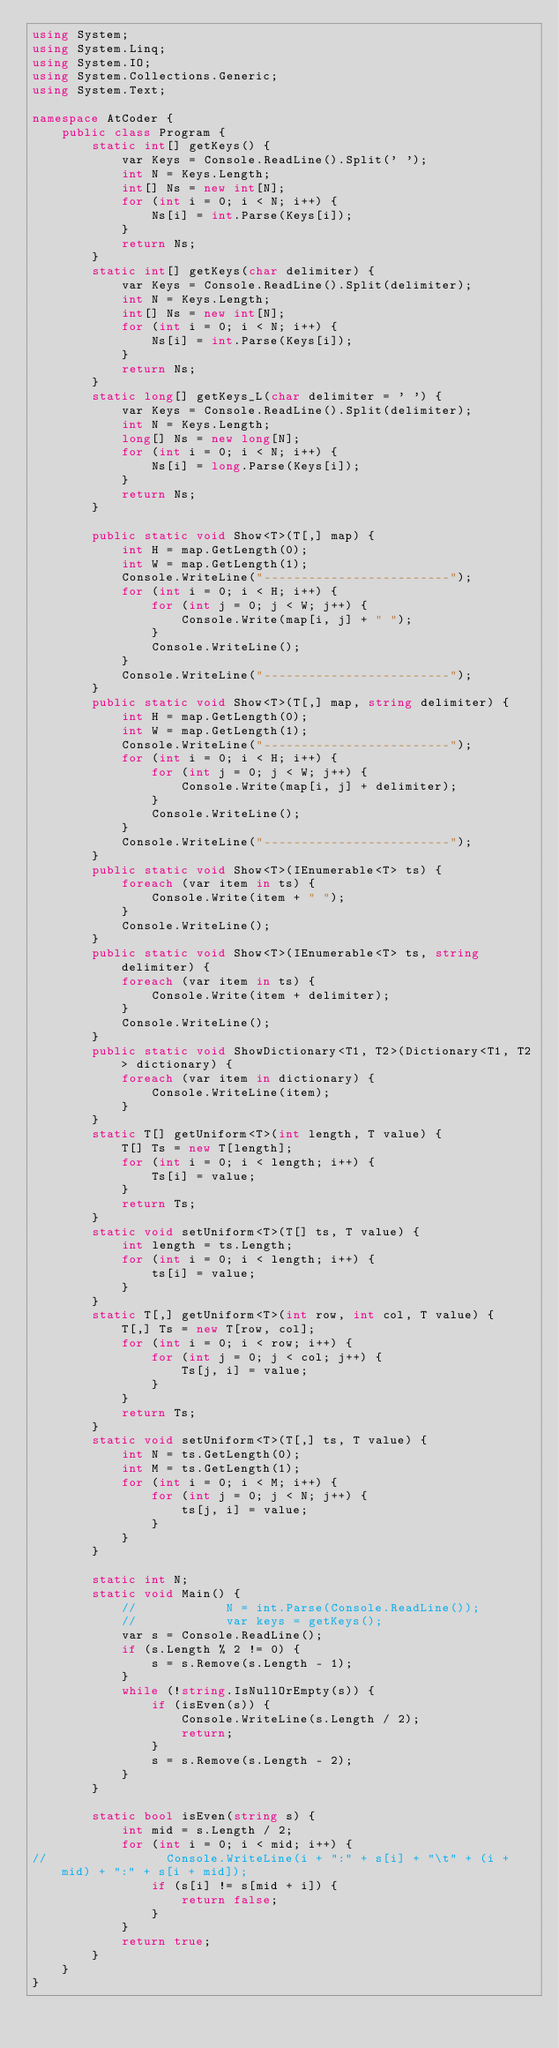<code> <loc_0><loc_0><loc_500><loc_500><_C#_>using System;
using System.Linq;
using System.IO;
using System.Collections.Generic;
using System.Text;

namespace AtCoder {
    public class Program {
        static int[] getKeys() {
            var Keys = Console.ReadLine().Split(' ');
            int N = Keys.Length;
            int[] Ns = new int[N];
            for (int i = 0; i < N; i++) {
                Ns[i] = int.Parse(Keys[i]);
            }
            return Ns;
        }
        static int[] getKeys(char delimiter) {
            var Keys = Console.ReadLine().Split(delimiter);
            int N = Keys.Length;
            int[] Ns = new int[N];
            for (int i = 0; i < N; i++) {
                Ns[i] = int.Parse(Keys[i]);
            }
            return Ns;
        }
        static long[] getKeys_L(char delimiter = ' ') {
            var Keys = Console.ReadLine().Split(delimiter);
            int N = Keys.Length;
            long[] Ns = new long[N];
            for (int i = 0; i < N; i++) {
                Ns[i] = long.Parse(Keys[i]);
            }
            return Ns;
        }

        public static void Show<T>(T[,] map) {
            int H = map.GetLength(0);
            int W = map.GetLength(1);
            Console.WriteLine("-------------------------");
            for (int i = 0; i < H; i++) {
                for (int j = 0; j < W; j++) {
                    Console.Write(map[i, j] + " ");
                }
                Console.WriteLine();
            }
            Console.WriteLine("-------------------------");
        }
        public static void Show<T>(T[,] map, string delimiter) {
            int H = map.GetLength(0);
            int W = map.GetLength(1);
            Console.WriteLine("-------------------------");
            for (int i = 0; i < H; i++) {
                for (int j = 0; j < W; j++) {
                    Console.Write(map[i, j] + delimiter);
                }
                Console.WriteLine();
            }
            Console.WriteLine("-------------------------");
        }
        public static void Show<T>(IEnumerable<T> ts) {
            foreach (var item in ts) {
                Console.Write(item + " ");
            }
            Console.WriteLine();
        }
        public static void Show<T>(IEnumerable<T> ts, string delimiter) {
            foreach (var item in ts) {
                Console.Write(item + delimiter);
            }
            Console.WriteLine();
        }
        public static void ShowDictionary<T1, T2>(Dictionary<T1, T2> dictionary) {
            foreach (var item in dictionary) {
                Console.WriteLine(item);
            }
        }
        static T[] getUniform<T>(int length, T value) {
            T[] Ts = new T[length];
            for (int i = 0; i < length; i++) {
                Ts[i] = value;
            }
            return Ts;
        }
        static void setUniform<T>(T[] ts, T value) {
            int length = ts.Length;
            for (int i = 0; i < length; i++) {
                ts[i] = value;
            }
        }
        static T[,] getUniform<T>(int row, int col, T value) {
            T[,] Ts = new T[row, col];
            for (int i = 0; i < row; i++) {
                for (int j = 0; j < col; j++) {
                    Ts[j, i] = value;
                }
            }
            return Ts;
        }
        static void setUniform<T>(T[,] ts, T value) {
            int N = ts.GetLength(0);
            int M = ts.GetLength(1);
            for (int i = 0; i < M; i++) {
                for (int j = 0; j < N; j++) {
                    ts[j, i] = value;
                }
            }
        }

        static int N;
        static void Main() {
            //            N = int.Parse(Console.ReadLine());
            //            var keys = getKeys();
            var s = Console.ReadLine();            
            if (s.Length % 2 != 0) {
                s = s.Remove(s.Length - 1);
            }
            while (!string.IsNullOrEmpty(s)) {
                if (isEven(s)) {
                    Console.WriteLine(s.Length / 2);
                    return;
                }
                s = s.Remove(s.Length - 2);
            }
        }

        static bool isEven(string s) {
            int mid = s.Length / 2;
            for (int i = 0; i < mid; i++) {
//                Console.WriteLine(i + ":" + s[i] + "\t" + (i + mid) + ":" + s[i + mid]);
                if (s[i] != s[mid + i]) {
                    return false;
                }
            }
            return true;
        }
    }
}</code> 